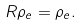<formula> <loc_0><loc_0><loc_500><loc_500>R \rho _ { e } = \rho _ { e } .</formula> 